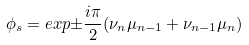<formula> <loc_0><loc_0><loc_500><loc_500>\phi _ { s } = e x p { \pm { \frac { i \pi } { 2 } } ( \nu _ { n } \mu _ { n - 1 } + \nu _ { n - 1 } \mu _ { n } ) }</formula> 